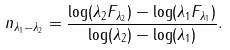<formula> <loc_0><loc_0><loc_500><loc_500>n _ { \lambda _ { 1 } - \lambda _ { 2 } } = \frac { \log ( \lambda _ { 2 } F _ { \lambda _ { 2 } } ) - \log ( \lambda _ { 1 } F _ { \lambda _ { 1 } } ) } { \log ( \lambda _ { 2 } ) - \log ( \lambda _ { 1 } ) } .</formula> 